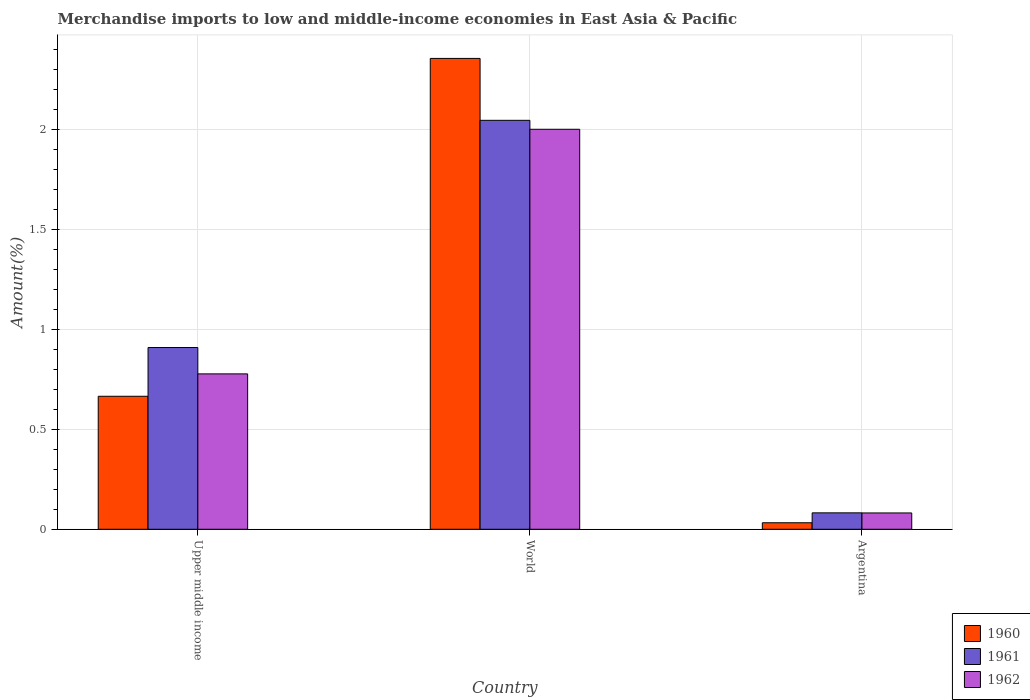How many bars are there on the 1st tick from the left?
Provide a short and direct response. 3. What is the label of the 2nd group of bars from the left?
Ensure brevity in your answer.  World. What is the percentage of amount earned from merchandise imports in 1960 in World?
Your answer should be very brief. 2.35. Across all countries, what is the maximum percentage of amount earned from merchandise imports in 1961?
Offer a terse response. 2.05. Across all countries, what is the minimum percentage of amount earned from merchandise imports in 1962?
Ensure brevity in your answer.  0.08. What is the total percentage of amount earned from merchandise imports in 1960 in the graph?
Provide a short and direct response. 3.05. What is the difference between the percentage of amount earned from merchandise imports in 1960 in Argentina and that in Upper middle income?
Your answer should be compact. -0.63. What is the difference between the percentage of amount earned from merchandise imports in 1962 in World and the percentage of amount earned from merchandise imports in 1960 in Argentina?
Your answer should be compact. 1.97. What is the average percentage of amount earned from merchandise imports in 1960 per country?
Your answer should be compact. 1.02. What is the difference between the percentage of amount earned from merchandise imports of/in 1962 and percentage of amount earned from merchandise imports of/in 1961 in Argentina?
Keep it short and to the point. -0. In how many countries, is the percentage of amount earned from merchandise imports in 1961 greater than 0.6 %?
Keep it short and to the point. 2. What is the ratio of the percentage of amount earned from merchandise imports in 1961 in Argentina to that in Upper middle income?
Offer a terse response. 0.09. What is the difference between the highest and the second highest percentage of amount earned from merchandise imports in 1961?
Provide a short and direct response. 0.83. What is the difference between the highest and the lowest percentage of amount earned from merchandise imports in 1962?
Your answer should be very brief. 1.92. Is the sum of the percentage of amount earned from merchandise imports in 1961 in Argentina and Upper middle income greater than the maximum percentage of amount earned from merchandise imports in 1960 across all countries?
Your answer should be very brief. No. What does the 2nd bar from the left in Upper middle income represents?
Offer a terse response. 1961. What does the 1st bar from the right in World represents?
Ensure brevity in your answer.  1962. Is it the case that in every country, the sum of the percentage of amount earned from merchandise imports in 1960 and percentage of amount earned from merchandise imports in 1962 is greater than the percentage of amount earned from merchandise imports in 1961?
Keep it short and to the point. Yes. What is the difference between two consecutive major ticks on the Y-axis?
Your answer should be very brief. 0.5. Are the values on the major ticks of Y-axis written in scientific E-notation?
Your response must be concise. No. Does the graph contain grids?
Provide a succinct answer. Yes. How are the legend labels stacked?
Offer a very short reply. Vertical. What is the title of the graph?
Your response must be concise. Merchandise imports to low and middle-income economies in East Asia & Pacific. Does "2006" appear as one of the legend labels in the graph?
Give a very brief answer. No. What is the label or title of the X-axis?
Your response must be concise. Country. What is the label or title of the Y-axis?
Offer a terse response. Amount(%). What is the Amount(%) in 1960 in Upper middle income?
Offer a terse response. 0.67. What is the Amount(%) in 1961 in Upper middle income?
Offer a terse response. 0.91. What is the Amount(%) of 1962 in Upper middle income?
Your answer should be very brief. 0.78. What is the Amount(%) in 1960 in World?
Provide a short and direct response. 2.35. What is the Amount(%) of 1961 in World?
Give a very brief answer. 2.05. What is the Amount(%) in 1962 in World?
Provide a short and direct response. 2. What is the Amount(%) of 1960 in Argentina?
Offer a terse response. 0.03. What is the Amount(%) of 1961 in Argentina?
Offer a very short reply. 0.08. What is the Amount(%) of 1962 in Argentina?
Make the answer very short. 0.08. Across all countries, what is the maximum Amount(%) in 1960?
Keep it short and to the point. 2.35. Across all countries, what is the maximum Amount(%) in 1961?
Give a very brief answer. 2.05. Across all countries, what is the maximum Amount(%) of 1962?
Give a very brief answer. 2. Across all countries, what is the minimum Amount(%) of 1960?
Offer a very short reply. 0.03. Across all countries, what is the minimum Amount(%) in 1961?
Offer a very short reply. 0.08. Across all countries, what is the minimum Amount(%) in 1962?
Your answer should be compact. 0.08. What is the total Amount(%) in 1960 in the graph?
Give a very brief answer. 3.05. What is the total Amount(%) in 1961 in the graph?
Offer a terse response. 3.04. What is the total Amount(%) of 1962 in the graph?
Provide a short and direct response. 2.86. What is the difference between the Amount(%) of 1960 in Upper middle income and that in World?
Keep it short and to the point. -1.69. What is the difference between the Amount(%) of 1961 in Upper middle income and that in World?
Ensure brevity in your answer.  -1.14. What is the difference between the Amount(%) in 1962 in Upper middle income and that in World?
Offer a terse response. -1.22. What is the difference between the Amount(%) of 1960 in Upper middle income and that in Argentina?
Offer a terse response. 0.63. What is the difference between the Amount(%) of 1961 in Upper middle income and that in Argentina?
Provide a short and direct response. 0.83. What is the difference between the Amount(%) in 1962 in Upper middle income and that in Argentina?
Your answer should be compact. 0.7. What is the difference between the Amount(%) of 1960 in World and that in Argentina?
Give a very brief answer. 2.32. What is the difference between the Amount(%) of 1961 in World and that in Argentina?
Ensure brevity in your answer.  1.96. What is the difference between the Amount(%) in 1962 in World and that in Argentina?
Provide a short and direct response. 1.92. What is the difference between the Amount(%) in 1960 in Upper middle income and the Amount(%) in 1961 in World?
Your answer should be compact. -1.38. What is the difference between the Amount(%) of 1960 in Upper middle income and the Amount(%) of 1962 in World?
Your answer should be very brief. -1.34. What is the difference between the Amount(%) of 1961 in Upper middle income and the Amount(%) of 1962 in World?
Offer a terse response. -1.09. What is the difference between the Amount(%) of 1960 in Upper middle income and the Amount(%) of 1961 in Argentina?
Offer a very short reply. 0.58. What is the difference between the Amount(%) in 1960 in Upper middle income and the Amount(%) in 1962 in Argentina?
Offer a terse response. 0.58. What is the difference between the Amount(%) of 1961 in Upper middle income and the Amount(%) of 1962 in Argentina?
Your answer should be compact. 0.83. What is the difference between the Amount(%) of 1960 in World and the Amount(%) of 1961 in Argentina?
Ensure brevity in your answer.  2.27. What is the difference between the Amount(%) in 1960 in World and the Amount(%) in 1962 in Argentina?
Keep it short and to the point. 2.27. What is the difference between the Amount(%) of 1961 in World and the Amount(%) of 1962 in Argentina?
Your answer should be very brief. 1.96. What is the average Amount(%) in 1960 per country?
Keep it short and to the point. 1.02. What is the average Amount(%) of 1961 per country?
Offer a terse response. 1.01. What is the average Amount(%) of 1962 per country?
Give a very brief answer. 0.95. What is the difference between the Amount(%) of 1960 and Amount(%) of 1961 in Upper middle income?
Your response must be concise. -0.24. What is the difference between the Amount(%) of 1960 and Amount(%) of 1962 in Upper middle income?
Offer a terse response. -0.11. What is the difference between the Amount(%) of 1961 and Amount(%) of 1962 in Upper middle income?
Offer a very short reply. 0.13. What is the difference between the Amount(%) in 1960 and Amount(%) in 1961 in World?
Your answer should be compact. 0.31. What is the difference between the Amount(%) in 1960 and Amount(%) in 1962 in World?
Your answer should be very brief. 0.35. What is the difference between the Amount(%) in 1961 and Amount(%) in 1962 in World?
Offer a terse response. 0.04. What is the difference between the Amount(%) in 1960 and Amount(%) in 1961 in Argentina?
Keep it short and to the point. -0.05. What is the difference between the Amount(%) in 1960 and Amount(%) in 1962 in Argentina?
Ensure brevity in your answer.  -0.05. What is the ratio of the Amount(%) of 1960 in Upper middle income to that in World?
Give a very brief answer. 0.28. What is the ratio of the Amount(%) of 1961 in Upper middle income to that in World?
Ensure brevity in your answer.  0.44. What is the ratio of the Amount(%) of 1962 in Upper middle income to that in World?
Offer a terse response. 0.39. What is the ratio of the Amount(%) in 1960 in Upper middle income to that in Argentina?
Your answer should be compact. 20.41. What is the ratio of the Amount(%) in 1961 in Upper middle income to that in Argentina?
Your response must be concise. 11.06. What is the ratio of the Amount(%) of 1962 in Upper middle income to that in Argentina?
Keep it short and to the point. 9.52. What is the ratio of the Amount(%) of 1960 in World to that in Argentina?
Your answer should be very brief. 72.25. What is the ratio of the Amount(%) in 1961 in World to that in Argentina?
Offer a very short reply. 24.89. What is the ratio of the Amount(%) of 1962 in World to that in Argentina?
Your answer should be very brief. 24.5. What is the difference between the highest and the second highest Amount(%) of 1960?
Provide a succinct answer. 1.69. What is the difference between the highest and the second highest Amount(%) of 1961?
Ensure brevity in your answer.  1.14. What is the difference between the highest and the second highest Amount(%) in 1962?
Make the answer very short. 1.22. What is the difference between the highest and the lowest Amount(%) in 1960?
Give a very brief answer. 2.32. What is the difference between the highest and the lowest Amount(%) in 1961?
Offer a terse response. 1.96. What is the difference between the highest and the lowest Amount(%) in 1962?
Provide a short and direct response. 1.92. 